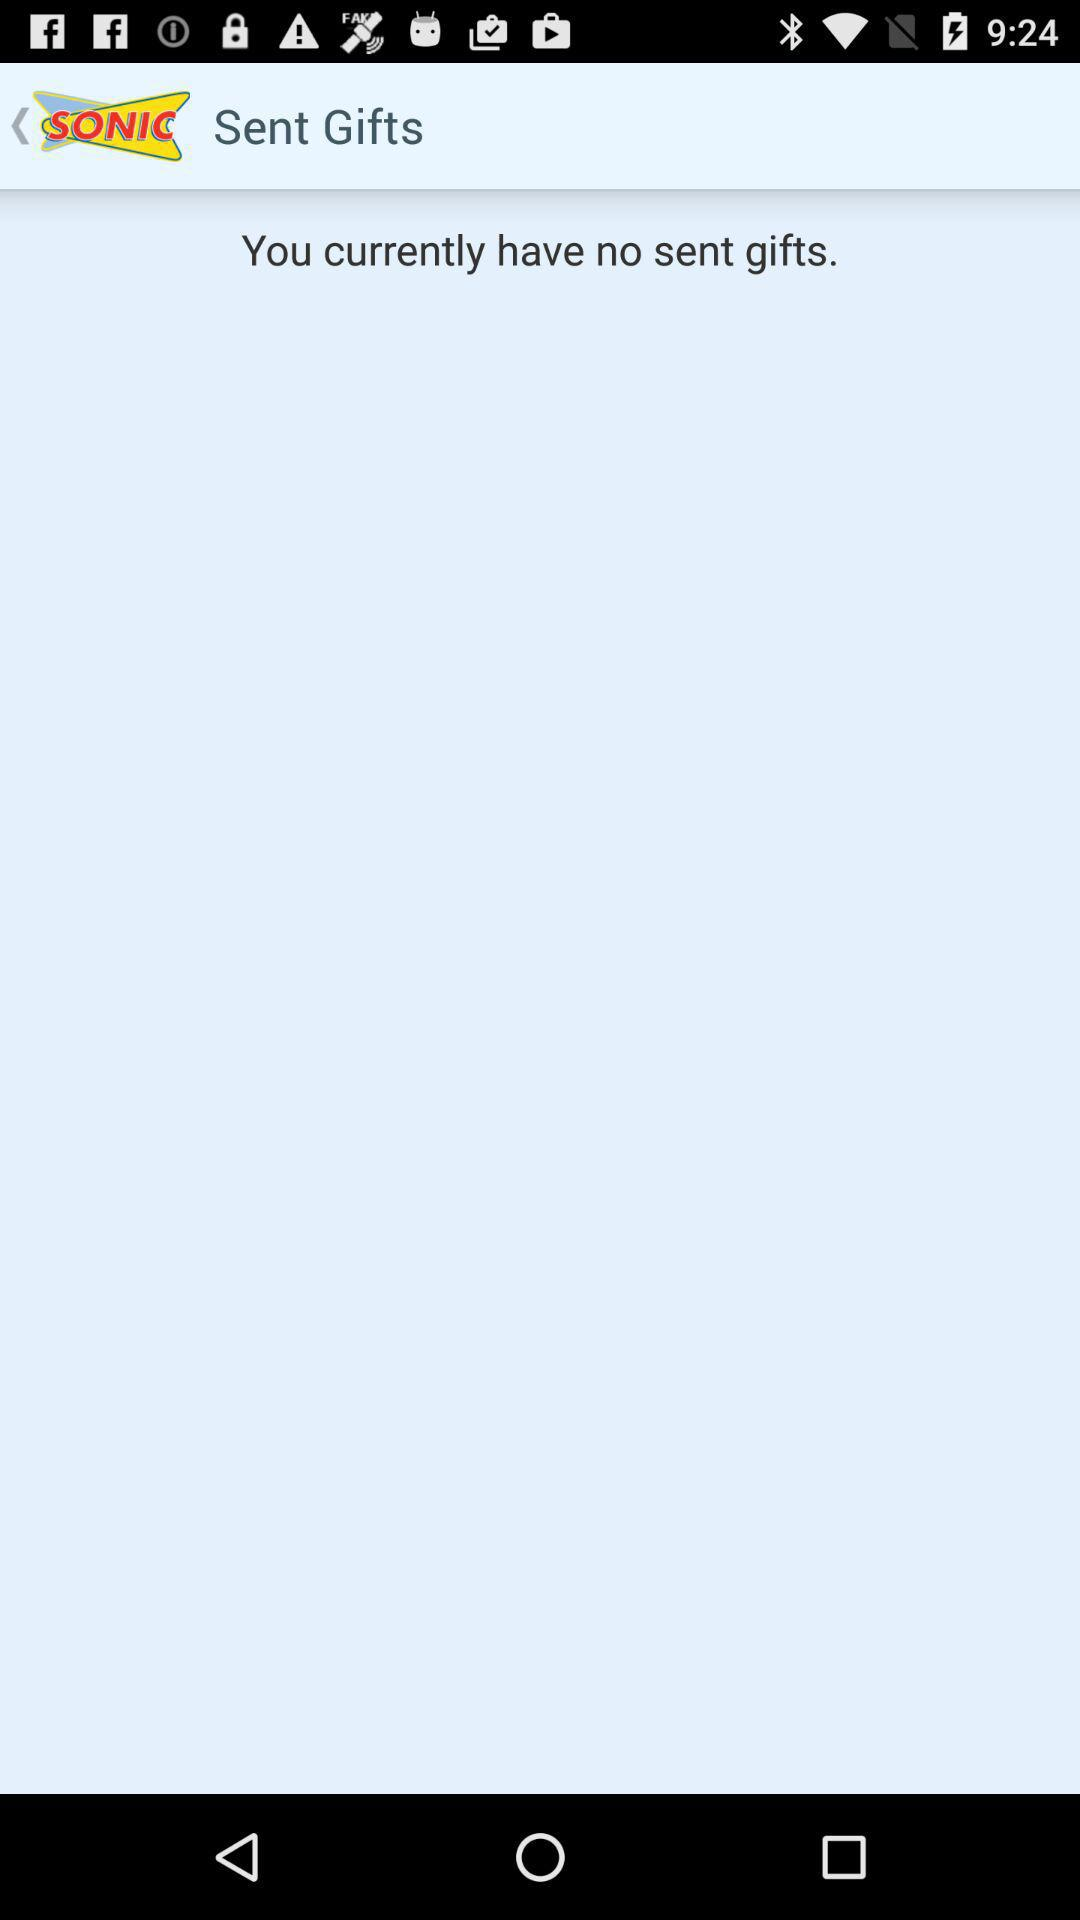What is the username?
When the provided information is insufficient, respond with <no answer>. <no answer> 